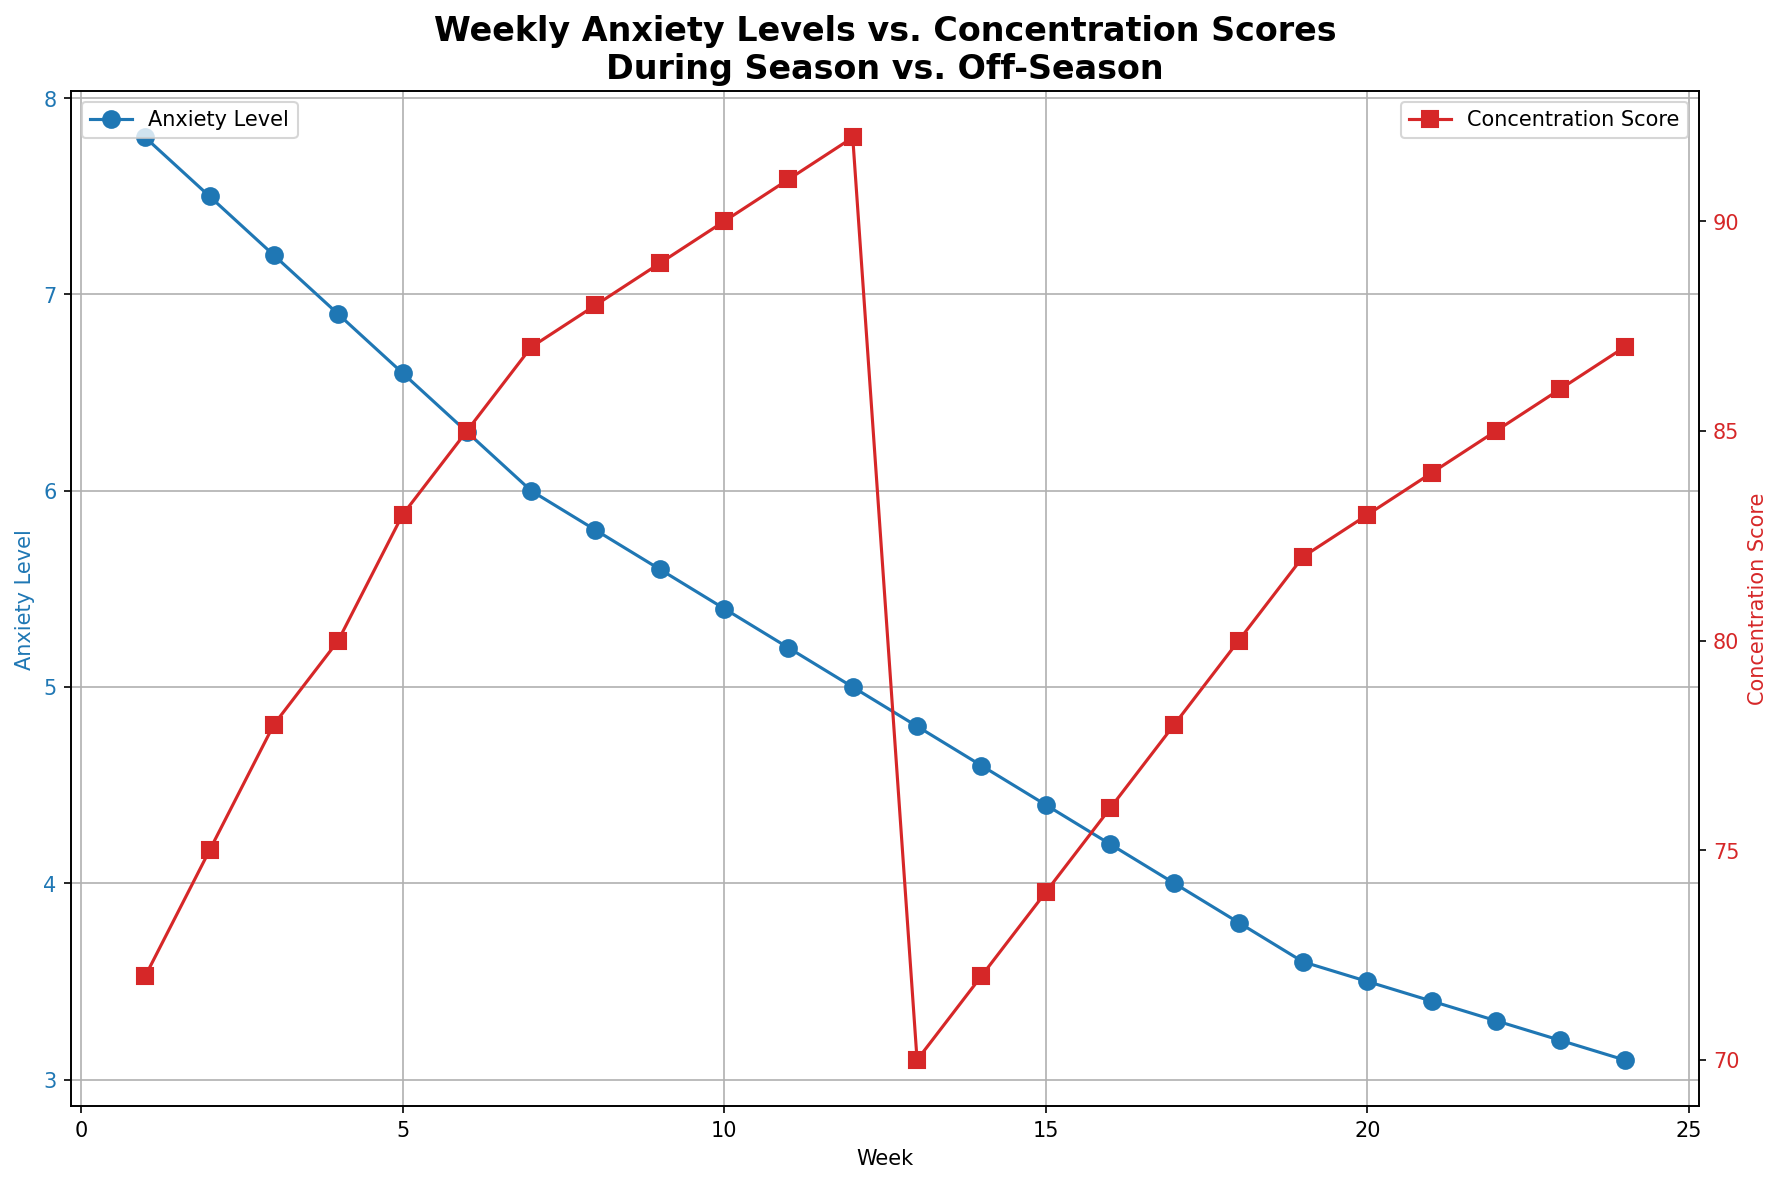What is the trend of Anxiety Levels during the season? The figure shows that Anxiety Levels during the season (weeks 1 to 12) generally decrease. Specifically, it starts around 7.8 in week 1 and drops steadily to 5.0 by week 12.
Answer: Decreasing How do the Concentration Scores change during the off-season compared to the regular season? During the season, Concentration Scores increase from week 1 to 12, starting at 72 and reaching 92. In the off-season, they increase again from week 13 to week 24, but the starting and ending points are lower, going from 70 to 87.
Answer: Lower starting and ending points in the off-season At what week do Anxiety Levels and Concentration Scores show the most noticeable crossover? The most noticeable crossover occurs between weeks 11 and 13, where Anxiety Levels drop significantly compared to previous weeks, while Concentration Scores slightly decrease from their peak.
Answer: Around week 12 Which week has the lowest recorded Anxiety Level? The lowest recorded Anxiety Level is in week 24 during the off-season with a value of 3.1.
Answer: Week 24 Which period shows a faster decrease in Anxiety Levels, season or off-season? The decrease in Anxiety Levels is faster during the off-season, where it drops from 4.8 to 3.1 within 12 weeks, compared to the season where it decreases from 7.8 to 5.0 in the same timeframe.
Answer: Off-season In what week does the Anxiety Level first drop below 6.0? Anxiety Levels first drop below 6.0 during week 7 of the season.
Answer: Week 7 Compare the Concentration Scores of week 1 of the season and week 13 of the off-season. Which one is higher? Week 1 of the season has a Concentration Score of 72, while week 13 of the off-season also has a score of 70. Thus, the Concentration Score is higher in week 1 of the season.
Answer: Week 1 of the season What is the average Anxiety Level during the off-season? The Anxiety Levels during the off-season (weeks 13 to 24) are 4.8, 4.6, 4.4, 4.2, 4.0, 3.8, 3.6, 3.5, 3.4, 3.3, 3.2, 3.1. Summing these and dividing by 12, (4.8 + 4.6 + 4.4 + 4.2 + 4.0 + 3.8 + 3.6 + 3.5 + 3.4 + 3.3 + 3.2 + 3.1) / 12 = 3.975.
Answer: 3.975 Which week has the highest Concentration Score? The highest Concentration Score is recorded in week 12 of the season with a value of 92.
Answer: Week 12 